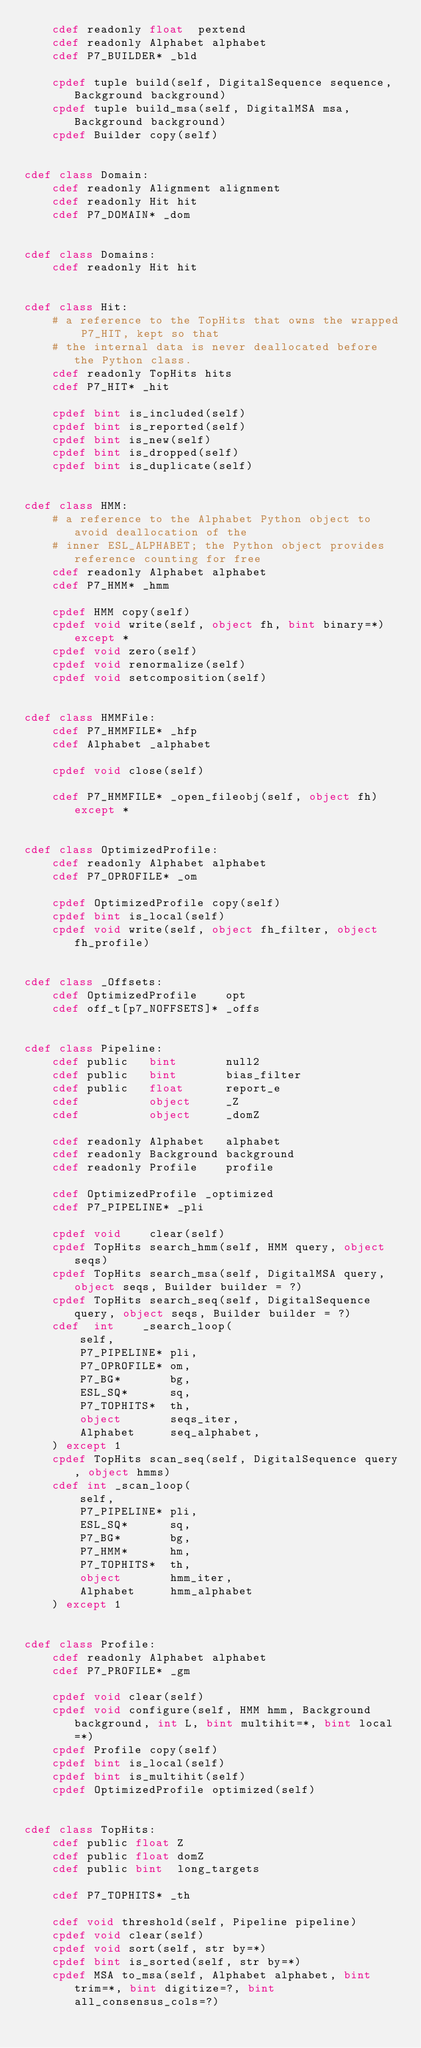Convert code to text. <code><loc_0><loc_0><loc_500><loc_500><_Cython_>    cdef readonly float  pextend
    cdef readonly Alphabet alphabet
    cdef P7_BUILDER* _bld

    cpdef tuple build(self, DigitalSequence sequence, Background background)
    cpdef tuple build_msa(self, DigitalMSA msa, Background background)
    cpdef Builder copy(self)


cdef class Domain:
    cdef readonly Alignment alignment
    cdef readonly Hit hit
    cdef P7_DOMAIN* _dom


cdef class Domains:
    cdef readonly Hit hit


cdef class Hit:
    # a reference to the TopHits that owns the wrapped P7_HIT, kept so that
    # the internal data is never deallocated before the Python class.
    cdef readonly TopHits hits
    cdef P7_HIT* _hit

    cpdef bint is_included(self)
    cpdef bint is_reported(self)
    cpdef bint is_new(self)
    cpdef bint is_dropped(self)
    cpdef bint is_duplicate(self)


cdef class HMM:
    # a reference to the Alphabet Python object to avoid deallocation of the
    # inner ESL_ALPHABET; the Python object provides reference counting for free
    cdef readonly Alphabet alphabet
    cdef P7_HMM* _hmm

    cpdef HMM copy(self)
    cpdef void write(self, object fh, bint binary=*) except *
    cpdef void zero(self)
    cpdef void renormalize(self)
    cpdef void setcomposition(self)


cdef class HMMFile:
    cdef P7_HMMFILE* _hfp
    cdef Alphabet _alphabet

    cpdef void close(self)

    cdef P7_HMMFILE* _open_fileobj(self, object fh) except *


cdef class OptimizedProfile:
    cdef readonly Alphabet alphabet
    cdef P7_OPROFILE* _om

    cpdef OptimizedProfile copy(self)
    cpdef bint is_local(self)
    cpdef void write(self, object fh_filter, object fh_profile)


cdef class _Offsets:
    cdef OptimizedProfile    opt
    cdef off_t[p7_NOFFSETS]* _offs


cdef class Pipeline:
    cdef public   bint       null2
    cdef public   bint       bias_filter
    cdef public   float      report_e
    cdef          object     _Z
    cdef          object     _domZ

    cdef readonly Alphabet   alphabet
    cdef readonly Background background
    cdef readonly Profile    profile

    cdef OptimizedProfile _optimized
    cdef P7_PIPELINE* _pli

    cpdef void    clear(self)
    cpdef TopHits search_hmm(self, HMM query, object seqs)
    cpdef TopHits search_msa(self, DigitalMSA query, object seqs, Builder builder = ?)
    cpdef TopHits search_seq(self, DigitalSequence query, object seqs, Builder builder = ?)
    cdef  int    _search_loop(
        self,
        P7_PIPELINE* pli,
        P7_OPROFILE* om,
        P7_BG*       bg,
        ESL_SQ*      sq,
        P7_TOPHITS*  th,
        object       seqs_iter,
        Alphabet     seq_alphabet,
    ) except 1
    cpdef TopHits scan_seq(self, DigitalSequence query, object hmms)
    cdef int _scan_loop(
        self,
        P7_PIPELINE* pli,
        ESL_SQ*      sq,
        P7_BG*       bg,
        P7_HMM*      hm,
        P7_TOPHITS*  th,
        object       hmm_iter,
        Alphabet     hmm_alphabet
    ) except 1


cdef class Profile:
    cdef readonly Alphabet alphabet
    cdef P7_PROFILE* _gm

    cpdef void clear(self)
    cpdef void configure(self, HMM hmm, Background background, int L, bint multihit=*, bint local=*)
    cpdef Profile copy(self)
    cpdef bint is_local(self)
    cpdef bint is_multihit(self)
    cpdef OptimizedProfile optimized(self)


cdef class TopHits:
    cdef public float Z
    cdef public float domZ
    cdef public bint  long_targets

    cdef P7_TOPHITS* _th

    cdef void threshold(self, Pipeline pipeline)
    cpdef void clear(self)
    cpdef void sort(self, str by=*)
    cpdef bint is_sorted(self, str by=*)
    cpdef MSA to_msa(self, Alphabet alphabet, bint trim=*, bint digitize=?, bint all_consensus_cols=?)
</code> 